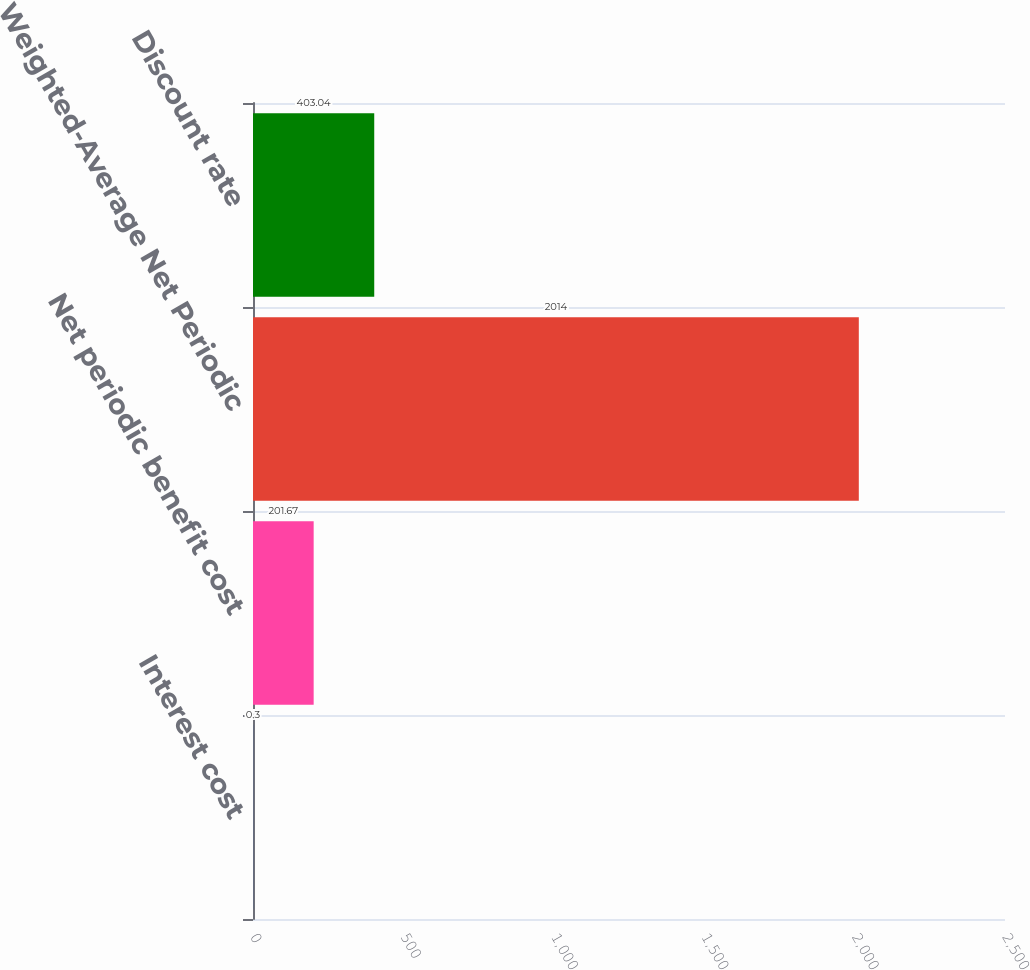Convert chart. <chart><loc_0><loc_0><loc_500><loc_500><bar_chart><fcel>Interest cost<fcel>Net periodic benefit cost<fcel>Weighted-Average Net Periodic<fcel>Discount rate<nl><fcel>0.3<fcel>201.67<fcel>2014<fcel>403.04<nl></chart> 